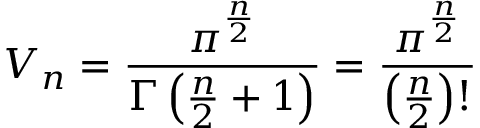<formula> <loc_0><loc_0><loc_500><loc_500>V _ { n } = { \frac { \pi ^ { \frac { n } { 2 } } } { \Gamma \left ( { \frac { n } { 2 } } + 1 \right ) } } = { \frac { \pi ^ { \frac { n } { 2 } } } { \left ( { \frac { n } { 2 } } \right ) ! } }</formula> 